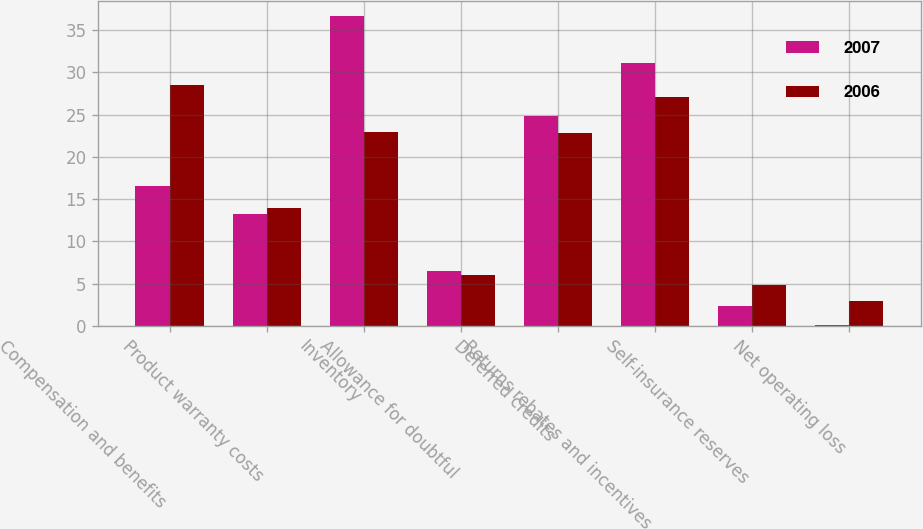Convert chart to OTSL. <chart><loc_0><loc_0><loc_500><loc_500><stacked_bar_chart><ecel><fcel>Compensation and benefits<fcel>Product warranty costs<fcel>Inventory<fcel>Allowance for doubtful<fcel>Deferred credits<fcel>Returns rebates and incentives<fcel>Self-insurance reserves<fcel>Net operating loss<nl><fcel>2007<fcel>16.5<fcel>13.2<fcel>36.6<fcel>6.5<fcel>24.8<fcel>31.1<fcel>2.4<fcel>0.1<nl><fcel>2006<fcel>28.5<fcel>13.9<fcel>22.9<fcel>6<fcel>22.8<fcel>27.1<fcel>4.8<fcel>2.9<nl></chart> 